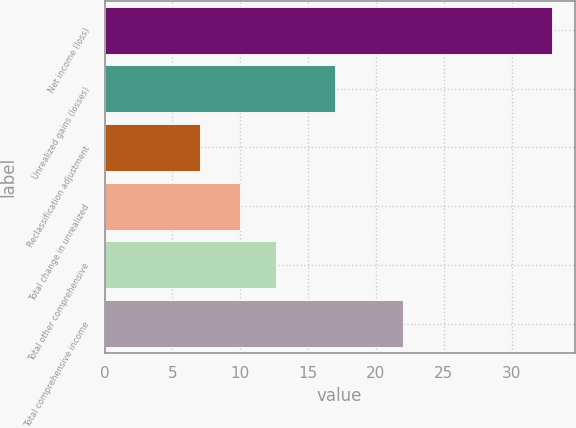Convert chart to OTSL. <chart><loc_0><loc_0><loc_500><loc_500><bar_chart><fcel>Net income (loss)<fcel>Unrealized gains (losses)<fcel>Reclassification adjustment<fcel>Total change in unrealized<fcel>Total other comprehensive<fcel>Total comprehensive income<nl><fcel>33<fcel>17<fcel>7<fcel>10<fcel>12.6<fcel>22<nl></chart> 